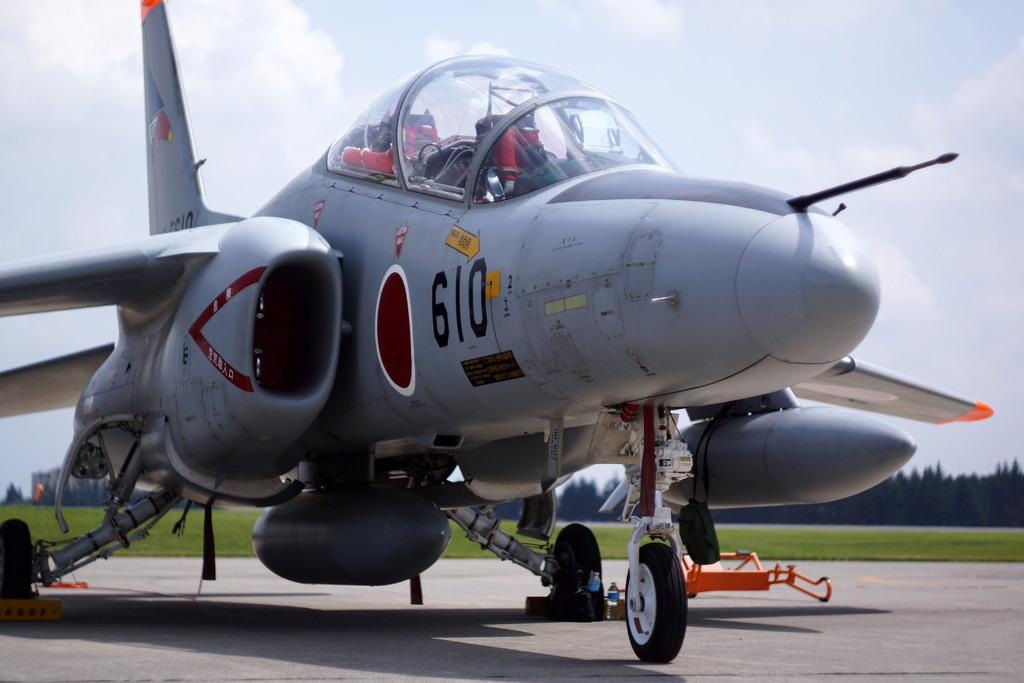What is the main subject in the foreground of the image? There is an aircraft in the foreground of the image. What can be seen at the bottom side of the image? There is an object at the bottom side of the image. What type of natural environment is visible in the background of the image? There are trees and grassland in the background of the image. What part of the natural environment is visible in the background of the image? The sky is visible in the background of the image. How does the tongue of the person in the image affect the light in the image? There is no person or tongue present in the image, so it is not possible to determine how the tongue might affect the light. 